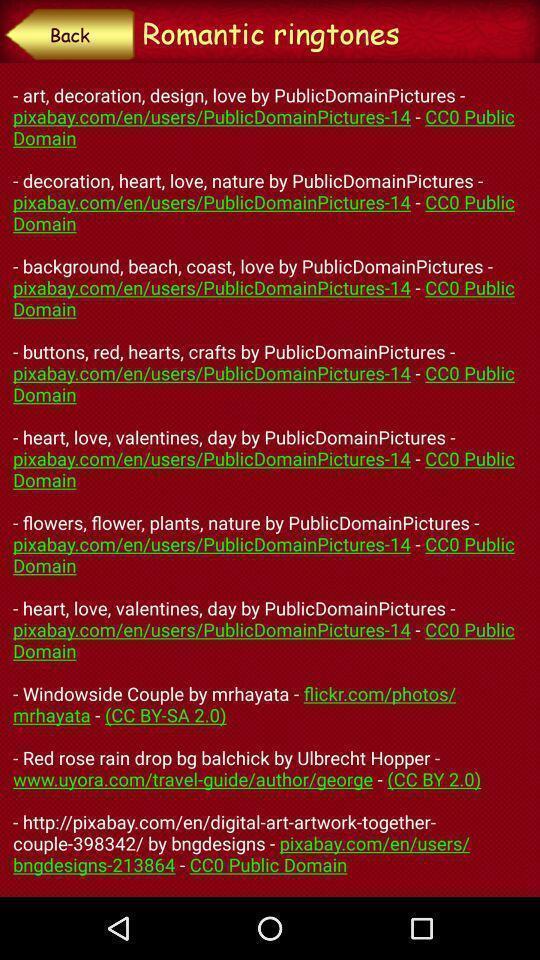Tell me about the visual elements in this screen capture. Screen shows about romantic ringtones. 